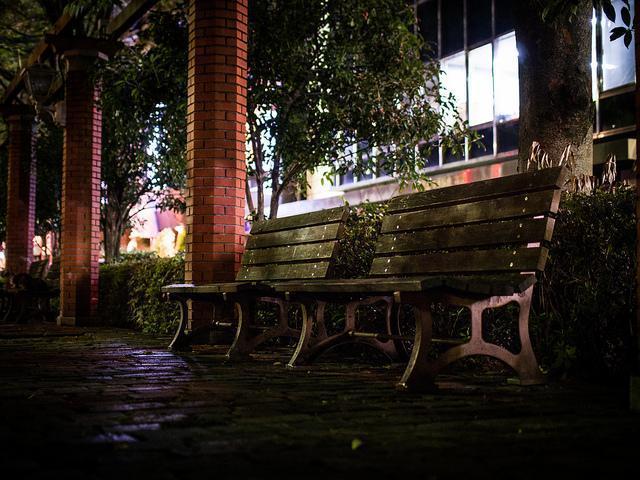How many benches are on the right?
Give a very brief answer. 2. How many people are sitting?
Give a very brief answer. 0. How many cows are stacked?
Give a very brief answer. 0. How many benches can be seen?
Give a very brief answer. 2. 